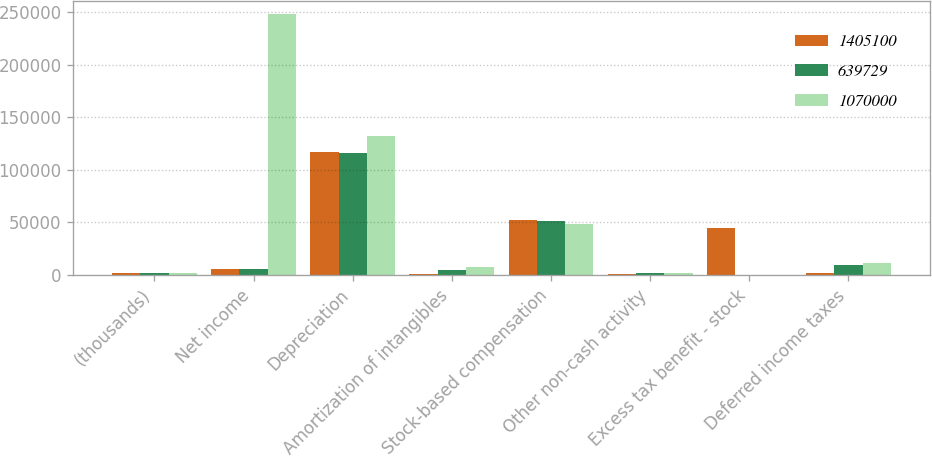Convert chart to OTSL. <chart><loc_0><loc_0><loc_500><loc_500><stacked_bar_chart><ecel><fcel>(thousands)<fcel>Net income<fcel>Depreciation<fcel>Amortization of intangibles<fcel>Stock-based compensation<fcel>Other non-cash activity<fcel>Excess tax benefit - stock<fcel>Deferred income taxes<nl><fcel>1.4051e+06<fcel>2011<fcel>6102.5<fcel>116873<fcel>1346<fcel>52358<fcel>833<fcel>44936<fcel>1704<nl><fcel>639729<fcel>2010<fcel>6102.5<fcel>116083<fcel>4828<fcel>51752<fcel>1662<fcel>317<fcel>9866<nl><fcel>1.07e+06<fcel>2009<fcel>247772<fcel>132493<fcel>7377<fcel>48613<fcel>1663<fcel>20<fcel>11595<nl></chart> 